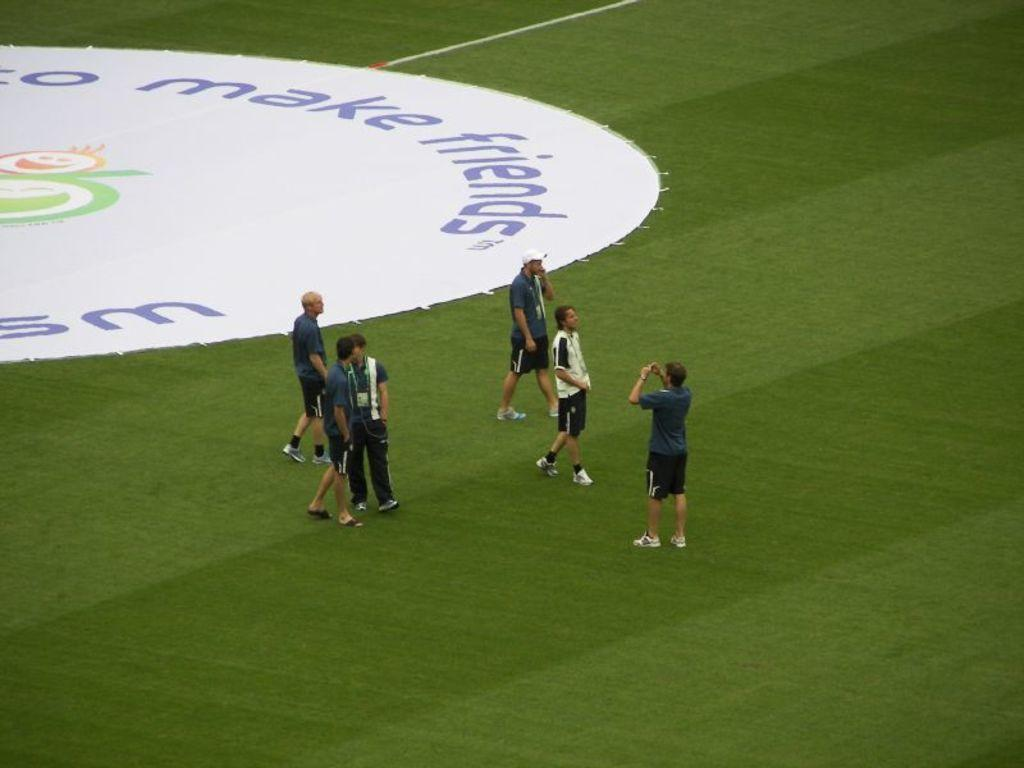<image>
Relay a brief, clear account of the picture shown. The stadium with players promoting Make Friends campaign. 